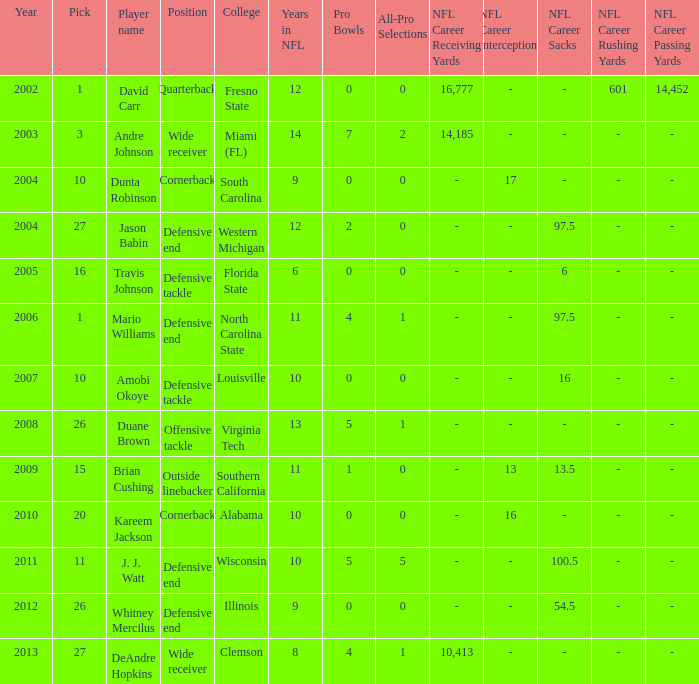What pick was mario williams before 2006? None. 